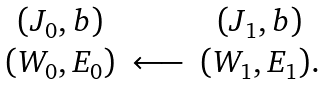Convert formula to latex. <formula><loc_0><loc_0><loc_500><loc_500>\begin{array} { c c c } ( J _ { 0 } , b ) & & ( J _ { 1 } , b ) \\ ( W _ { 0 } , E _ { 0 } ) & \longleftarrow & ( W _ { 1 } , E _ { 1 } ) . \end{array}</formula> 